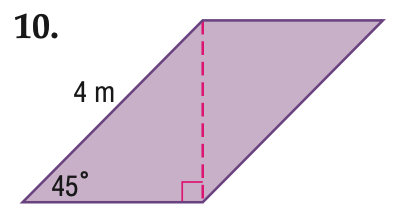Answer the mathemtical geometry problem and directly provide the correct option letter.
Question: Find the perimeter of the parallelogram. Round to the nearest tenth if necessary.
Choices: A: 10 B: 13.7 C: 14.9 D: 16 B 